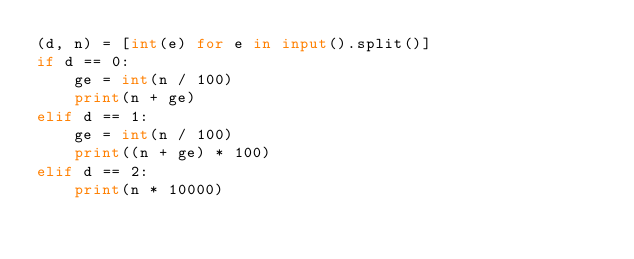<code> <loc_0><loc_0><loc_500><loc_500><_Python_>(d, n) = [int(e) for e in input().split()]
if d == 0:
    ge = int(n / 100)
    print(n + ge)
elif d == 1:
    ge = int(n / 100)
    print((n + ge) * 100)
elif d == 2:
    print(n * 10000)
</code> 